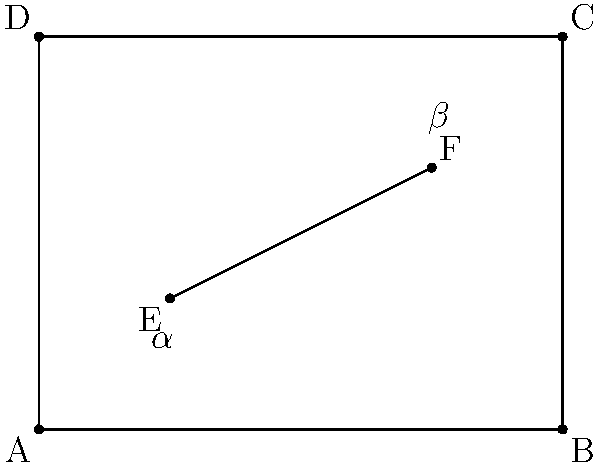In this artistic composition, a canvas is represented by rectangle ABCD, with an intersecting line EF. If the angle $\alpha$ formed by line EF and side AB is 30°, what is the measure of angle $\beta$ formed by line EF and side BC? How might this angular relationship contribute to the ethical implications of balance and harmony in the artwork? To solve this problem, we'll follow these steps:

1) First, recall that when a line intersects two parallel lines, corresponding angles are congruent. In this case, sides AB and DC are parallel, as are sides AD and BC.

2) The line EF intersects these parallel sides, creating corresponding angles. Therefore, the angle that EF makes with BC (angle $\beta$) is congruent to the angle it makes with AB (angle $\alpha$).

3) We're given that angle $\alpha$ is 30°. Due to the corresponding angle theorem, angle $\beta$ must also be 30°.

4) To verify, we can use the fact that the sum of angles on a straight line is 180°. The angle that EF makes with BC plus $\beta$ must equal 90° (since BC is perpendicular to AB). Indeed, 60° + 30° = 90°, confirming our result.

5) From an ethical perspective in art, this balance of angles could represent harmony and equilibrium. The equal angles on opposite sides of the canvas might symbolize fairness or justice, while the intersection itself could represent the meeting of different viewpoints or ideas. The simplicity and symmetry of the 30° angles might also evoke a sense of honesty or truth in composition.

6) Moreover, the intentional use of these angles in composition could raise questions about the artist's responsibility in creating balanced, harmonious works versus challenging or disruptive pieces. This geometric relationship thus becomes a metaphor for broader ethical considerations in artistic practice.
Answer: $30°$ 